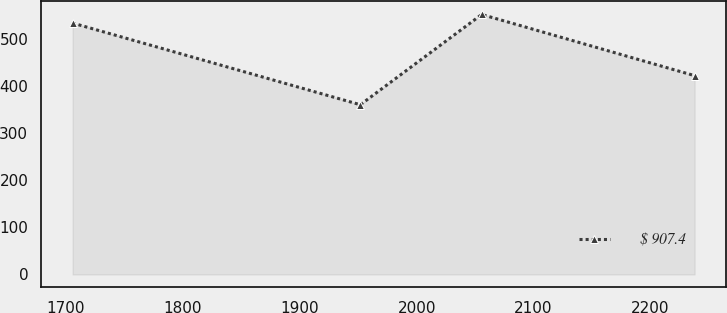Convert chart. <chart><loc_0><loc_0><loc_500><loc_500><line_chart><ecel><fcel>$ 907.4<nl><fcel>1705.61<fcel>533.73<nl><fcel>1951.78<fcel>360.32<nl><fcel>2055.62<fcel>551.92<nl><fcel>2237.73<fcel>422.1<nl></chart> 